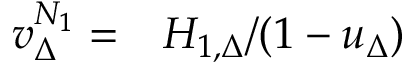Convert formula to latex. <formula><loc_0><loc_0><loc_500><loc_500>\begin{array} { r l } { v _ { \Delta } ^ { N _ { 1 } } = } & H _ { 1 , \Delta } / ( 1 - u _ { \Delta } ) } \end{array}</formula> 